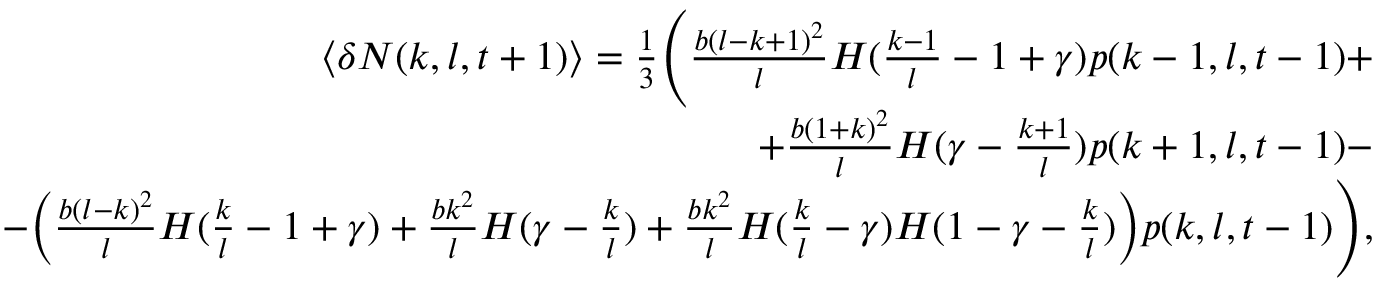<formula> <loc_0><loc_0><loc_500><loc_500>\begin{array} { r } { \langle \delta N ( k , l , t + 1 ) \rangle = \frac { 1 } { 3 } \left ( \frac { b ( l - k + 1 ) ^ { 2 } } { l } H ( \frac { k - 1 } { l } - 1 + \gamma ) p ( k - 1 , l , t - 1 ) + } \\ { + \frac { b ( 1 + k ) ^ { 2 } } { l } H ( \gamma - \frac { k + 1 } { l } ) p ( k + 1 , l , t - 1 ) - } \\ { - \left ( \frac { b ( l - k ) ^ { 2 } } { l } H ( \frac { k } { l } - 1 + \gamma ) + \frac { b k ^ { 2 } } { l } H ( \gamma - \frac { k } { l } ) + \frac { b k ^ { 2 } } { l } H ( \frac { k } { l } - \gamma ) H ( 1 - \gamma - \frac { k } { l } ) \right ) p ( k , l , t - 1 ) \right ) , } \end{array}</formula> 